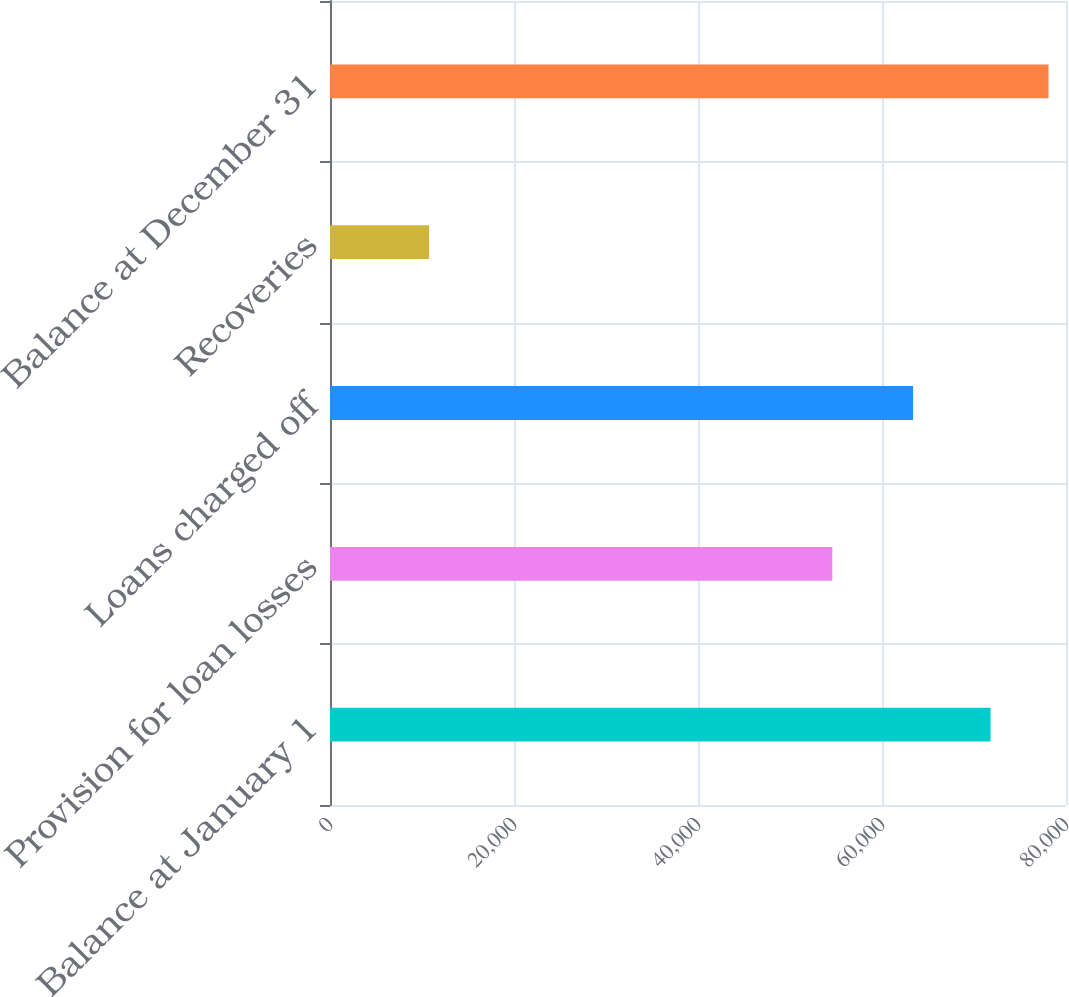Convert chart to OTSL. <chart><loc_0><loc_0><loc_500><loc_500><bar_chart><fcel>Balance at January 1<fcel>Provision for loan losses<fcel>Loans charged off<fcel>Recoveries<fcel>Balance at December 31<nl><fcel>71800<fcel>54602<fcel>63380<fcel>10778<fcel>78102.2<nl></chart> 